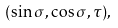<formula> <loc_0><loc_0><loc_500><loc_500>( \sin \sigma , \cos \sigma , \tau ) ,</formula> 